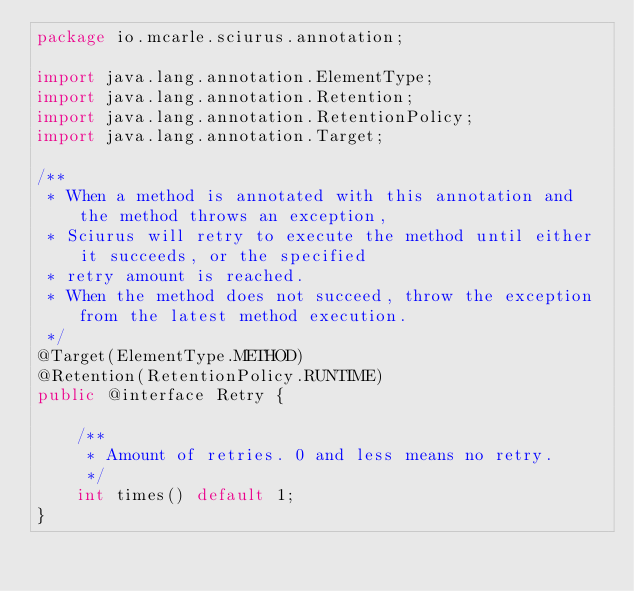Convert code to text. <code><loc_0><loc_0><loc_500><loc_500><_Java_>package io.mcarle.sciurus.annotation;

import java.lang.annotation.ElementType;
import java.lang.annotation.Retention;
import java.lang.annotation.RetentionPolicy;
import java.lang.annotation.Target;

/**
 * When a method is annotated with this annotation and the method throws an exception,
 * Sciurus will retry to execute the method until either it succeeds, or the specified
 * retry amount is reached.
 * When the method does not succeed, throw the exception from the latest method execution.
 */
@Target(ElementType.METHOD)
@Retention(RetentionPolicy.RUNTIME)
public @interface Retry {

    /**
     * Amount of retries. 0 and less means no retry.
     */
    int times() default 1;
}
</code> 